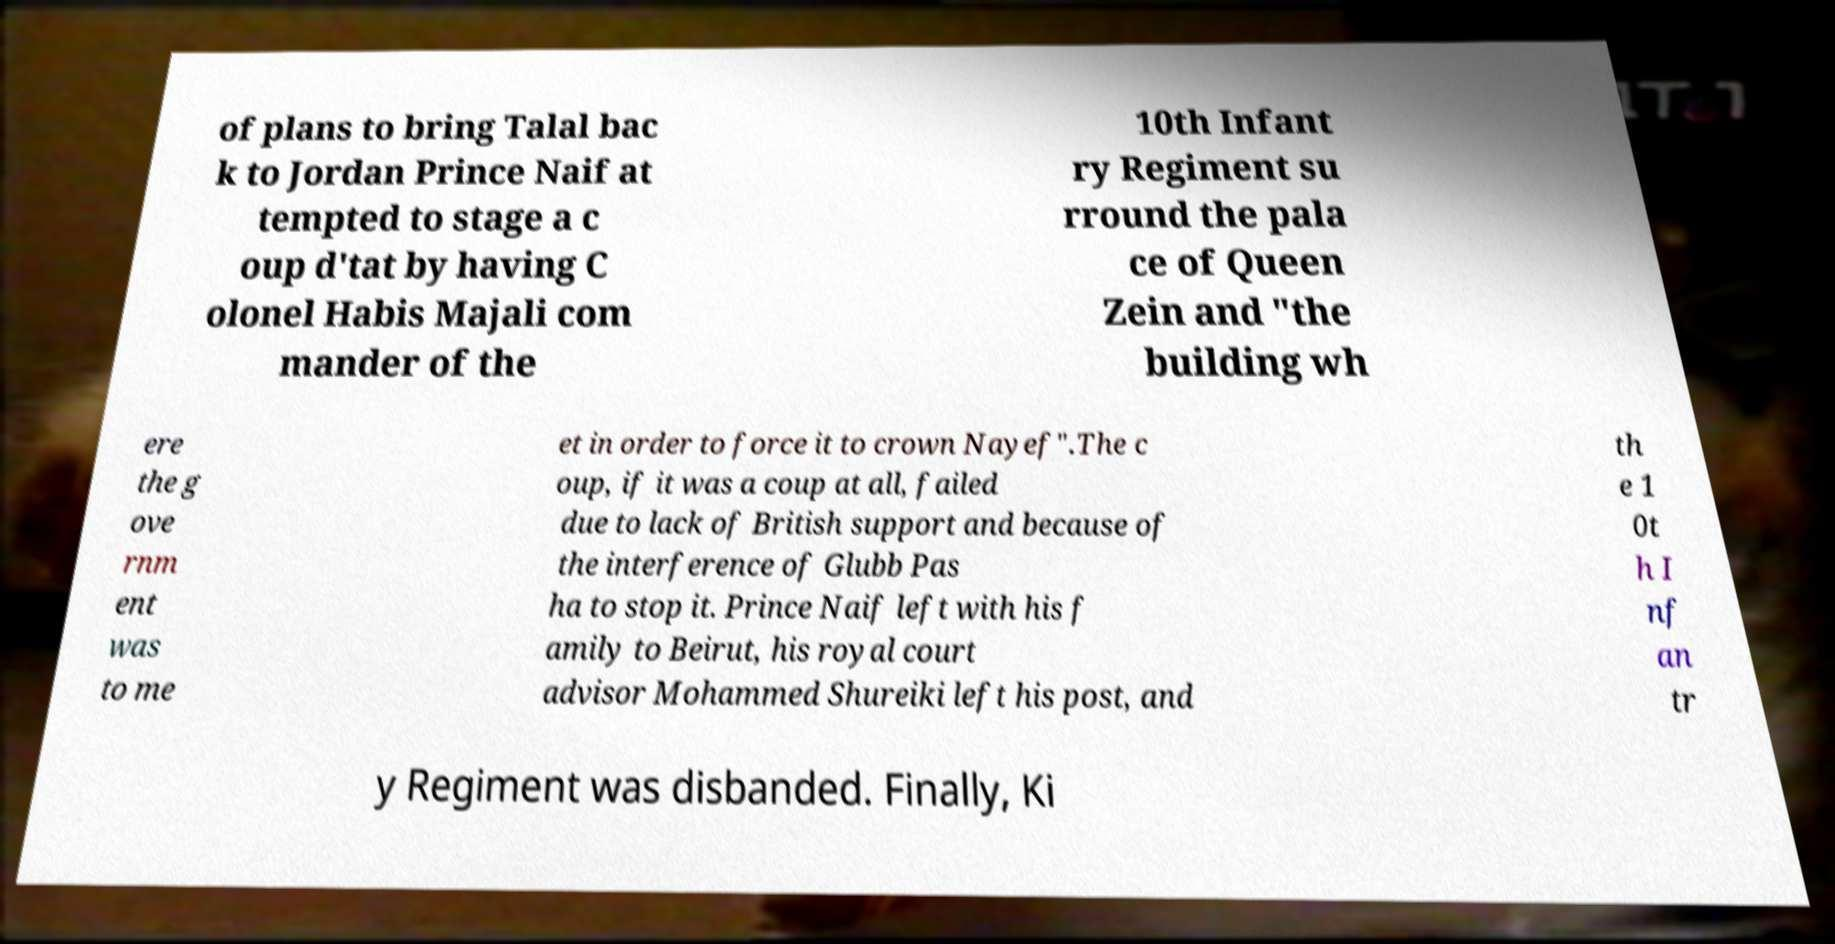There's text embedded in this image that I need extracted. Can you transcribe it verbatim? of plans to bring Talal bac k to Jordan Prince Naif at tempted to stage a c oup d'tat by having C olonel Habis Majali com mander of the 10th Infant ry Regiment su rround the pala ce of Queen Zein and "the building wh ere the g ove rnm ent was to me et in order to force it to crown Nayef".The c oup, if it was a coup at all, failed due to lack of British support and because of the interference of Glubb Pas ha to stop it. Prince Naif left with his f amily to Beirut, his royal court advisor Mohammed Shureiki left his post, and th e 1 0t h I nf an tr y Regiment was disbanded. Finally, Ki 